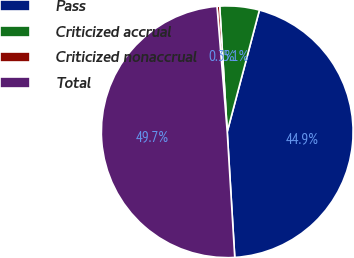Convert chart. <chart><loc_0><loc_0><loc_500><loc_500><pie_chart><fcel>Pass<fcel>Criticized accrual<fcel>Criticized nonaccrual<fcel>Total<nl><fcel>44.93%<fcel>5.07%<fcel>0.34%<fcel>49.66%<nl></chart> 